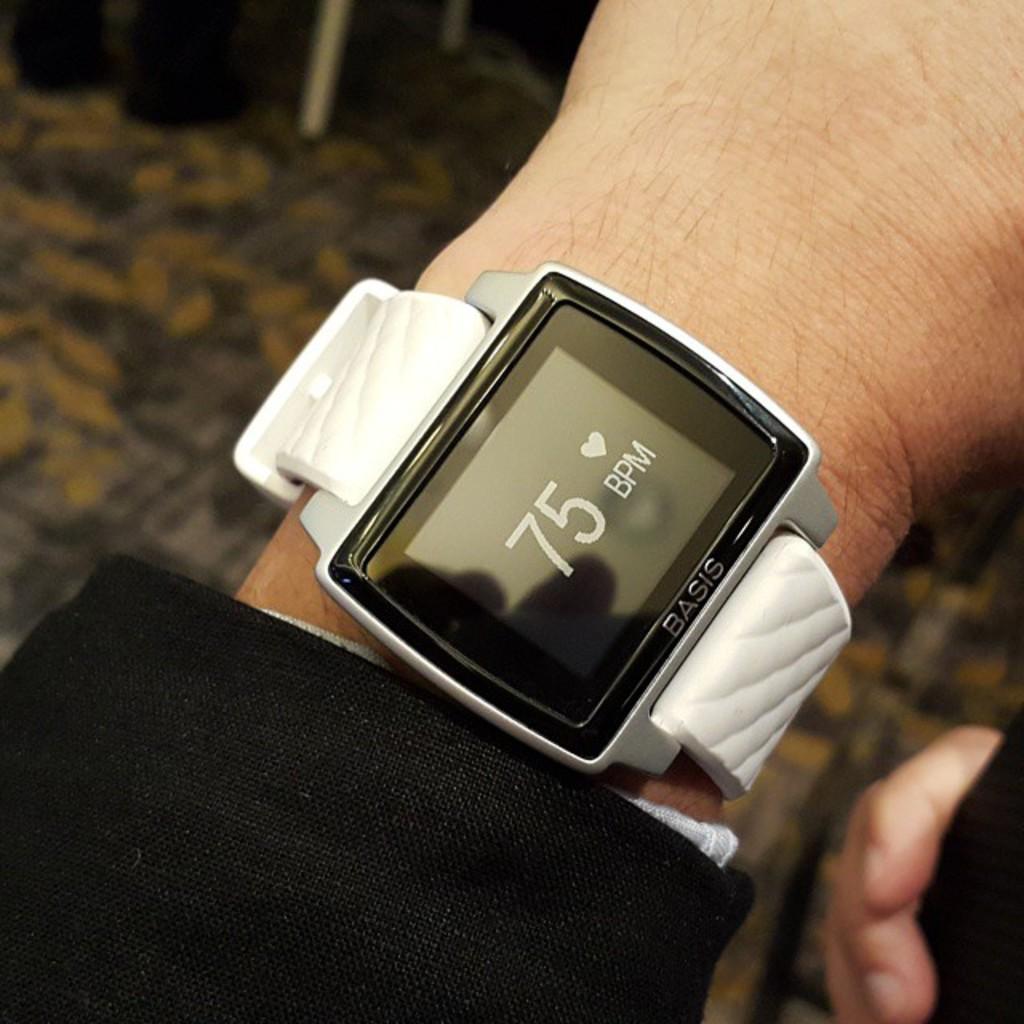Could you give a brief overview of what you see in this image? In this picture we can see a person wore a digital watch and in the background we can see an object on the floor and it is blurry. 